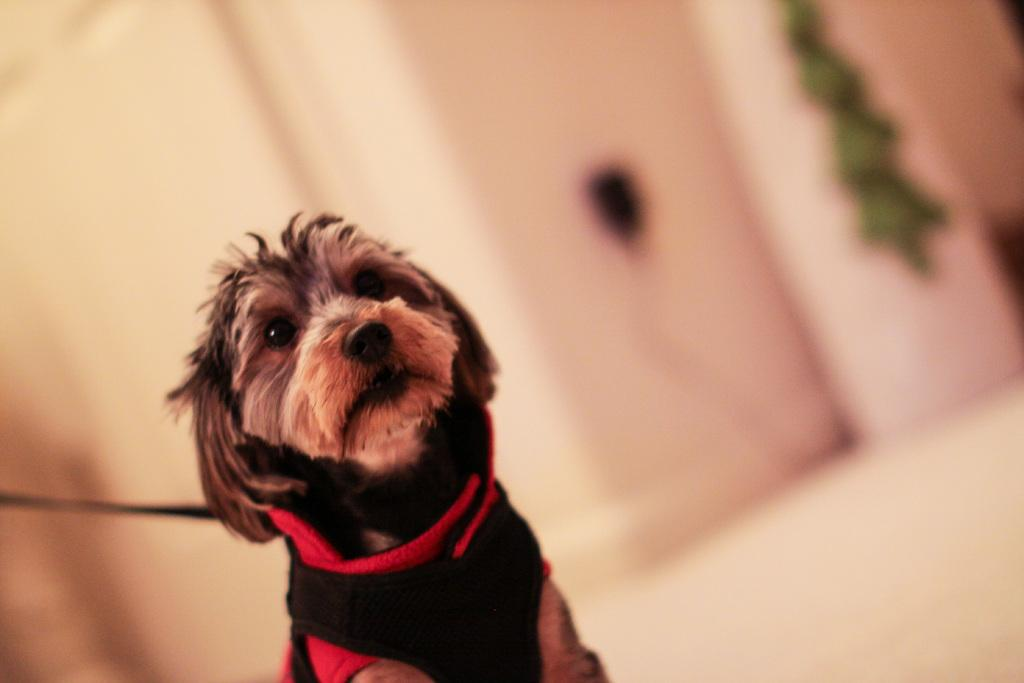What type of animal is in the image? There is a dog in the image. Can you describe the background of the image? The background of the image is blurry. What caption is written below the dog in the image? There is no caption present in the image; it only contains a dog and a blurry background. 